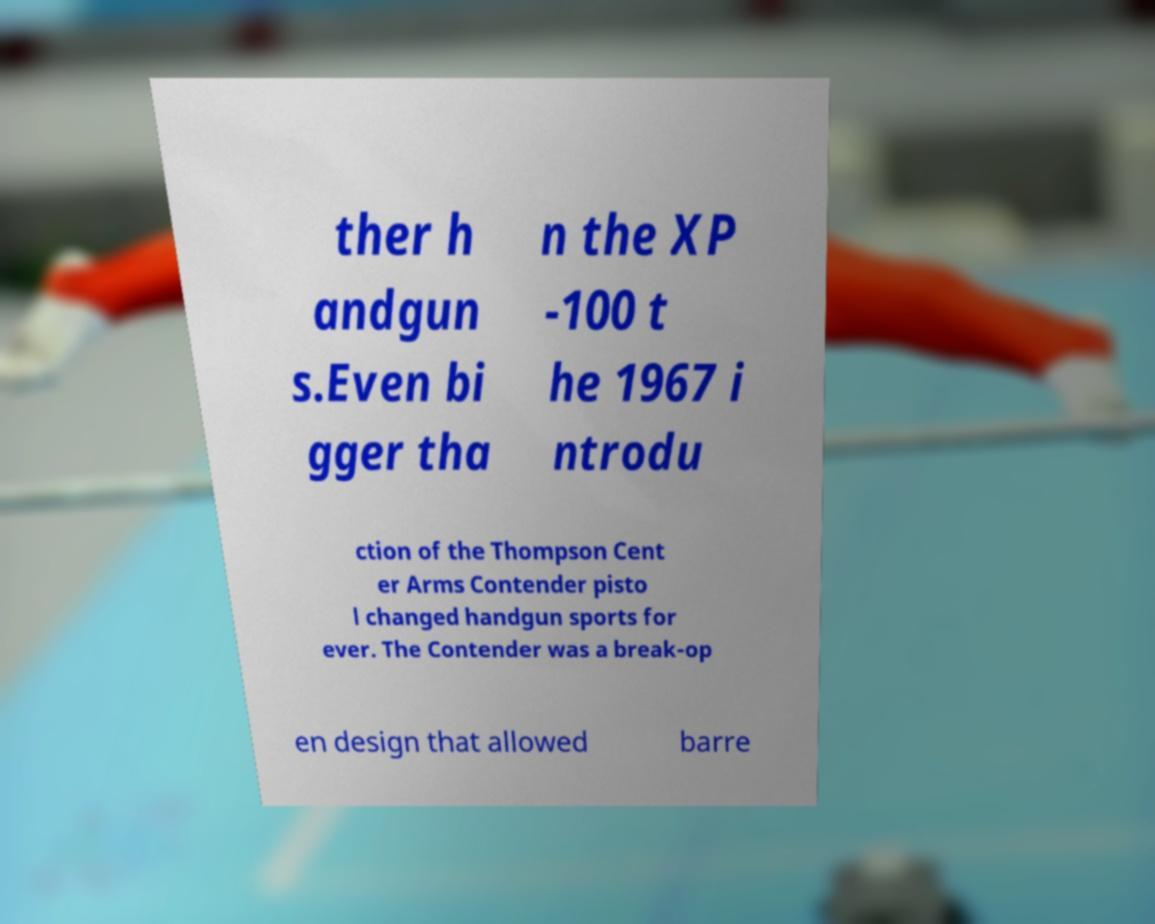Can you read and provide the text displayed in the image?This photo seems to have some interesting text. Can you extract and type it out for me? ther h andgun s.Even bi gger tha n the XP -100 t he 1967 i ntrodu ction of the Thompson Cent er Arms Contender pisto l changed handgun sports for ever. The Contender was a break-op en design that allowed barre 